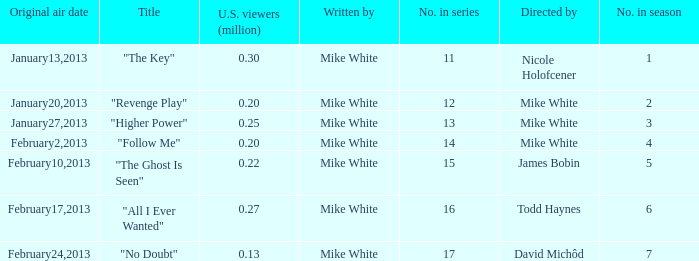Who directed the episode that have 0.25 million u.s viewers Mike White. 